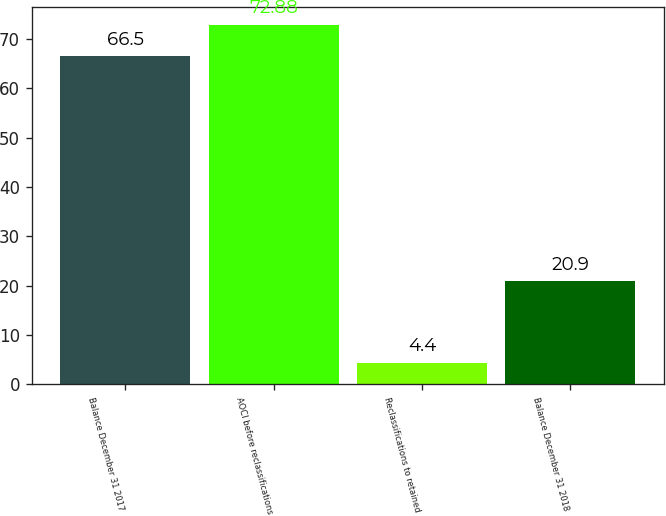<chart> <loc_0><loc_0><loc_500><loc_500><bar_chart><fcel>Balance December 31 2017<fcel>AOCI before reclassifications<fcel>Reclassifications to retained<fcel>Balance December 31 2018<nl><fcel>66.5<fcel>72.88<fcel>4.4<fcel>20.9<nl></chart> 